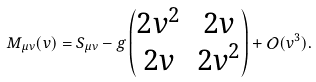<formula> <loc_0><loc_0><loc_500><loc_500>M _ { \mu \nu } ( v ) = S _ { \mu \nu } - g \begin{pmatrix} 2 v ^ { 2 } & 2 v \\ 2 v & 2 v ^ { 2 } \end{pmatrix} + \mathcal { O } ( v ^ { 3 } ) .</formula> 